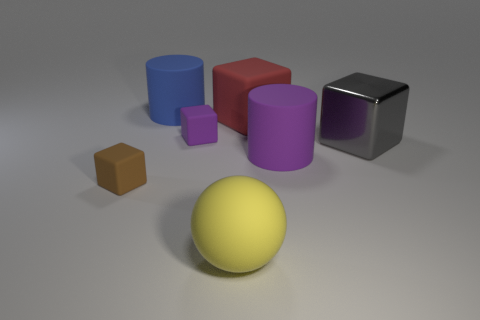Is there any other thing that has the same shape as the large red object?
Make the answer very short. Yes. What is the color of the object that is both to the right of the large red rubber object and left of the big gray metallic thing?
Ensure brevity in your answer.  Purple. How many cubes are blue matte objects or large yellow objects?
Offer a terse response. 0. What number of blue matte objects are the same size as the purple cylinder?
Your answer should be very brief. 1. How many big yellow matte balls are behind the big rubber cylinder in front of the red matte object?
Provide a succinct answer. 0. How big is the rubber thing that is on the left side of the small purple rubber cube and in front of the large gray metallic thing?
Offer a terse response. Small. Are there more small gray rubber cylinders than red rubber cubes?
Offer a terse response. No. Do the rubber cube in front of the metal thing and the gray metallic object have the same size?
Keep it short and to the point. No. Is the number of small purple blocks less than the number of large yellow metallic objects?
Your answer should be compact. No. Is there a yellow ball made of the same material as the gray block?
Offer a very short reply. No. 